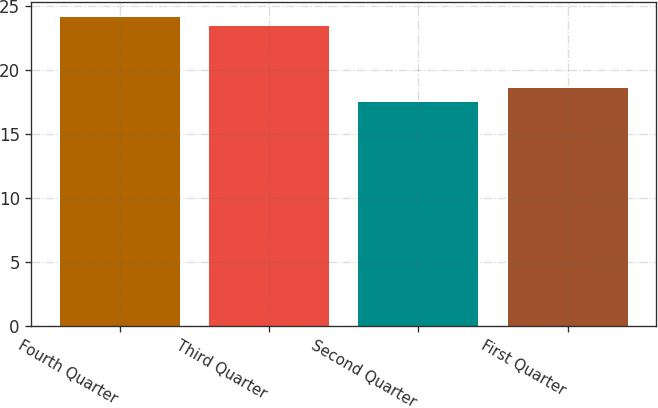Convert chart. <chart><loc_0><loc_0><loc_500><loc_500><bar_chart><fcel>Fourth Quarter<fcel>Third Quarter<fcel>Second Quarter<fcel>First Quarter<nl><fcel>24.15<fcel>23.5<fcel>17.5<fcel>18.62<nl></chart> 